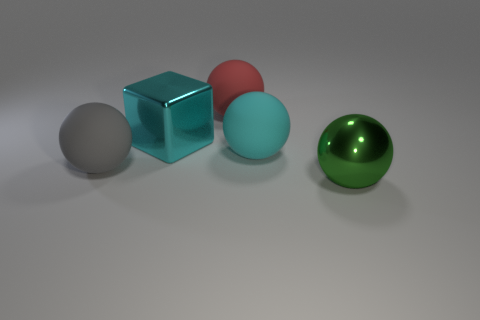How might the positioning of the objects contribute to the composition of this image? The arrangement of objects creates a balanced composition through their placement along an implied diagonal line, leading the viewer's eye through the image. The variation in color and shape between the cube and the spheres also adds visual interest and a sense of harmony. 